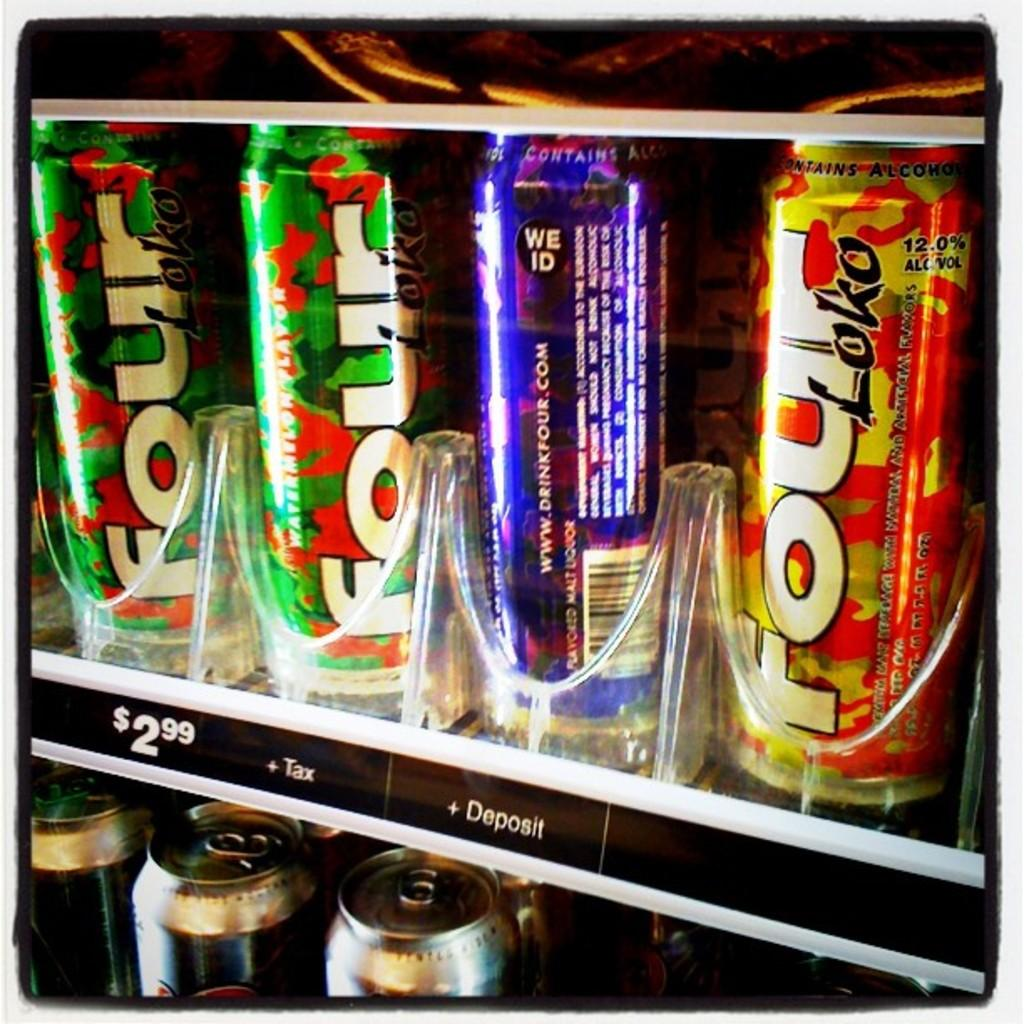<image>
Provide a brief description of the given image. Bottles inside a vending machine with one saying Loko on it. 